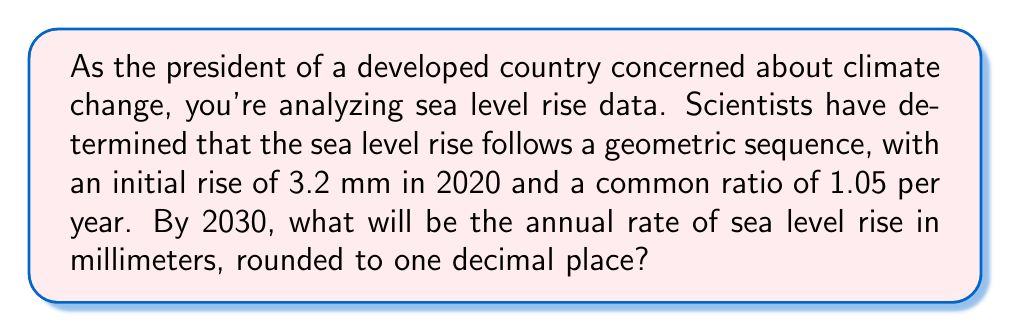Help me with this question. To solve this problem, we'll use the formula for the nth term of a geometric sequence:

$$a_n = a_1 \cdot r^{n-1}$$

Where:
$a_n$ is the nth term (the sea level rise in 2030)
$a_1$ is the first term (3.2 mm in 2020)
$r$ is the common ratio (1.05)
$n$ is the number of years from 2020 to 2030 (11)

Let's plug in these values:

$$a_{11} = 3.2 \cdot 1.05^{11-1}$$
$$a_{11} = 3.2 \cdot 1.05^{10}$$

Now, let's calculate:

$$a_{11} = 3.2 \cdot (1.6288946267)$$
$$a_{11} = 5.2124628054$$

Rounding to one decimal place:

$$a_{11} \approx 5.2 \text{ mm}$$

This means that by 2030, the annual sea level rise will be approximately 5.2 mm.
Answer: 5.2 mm 